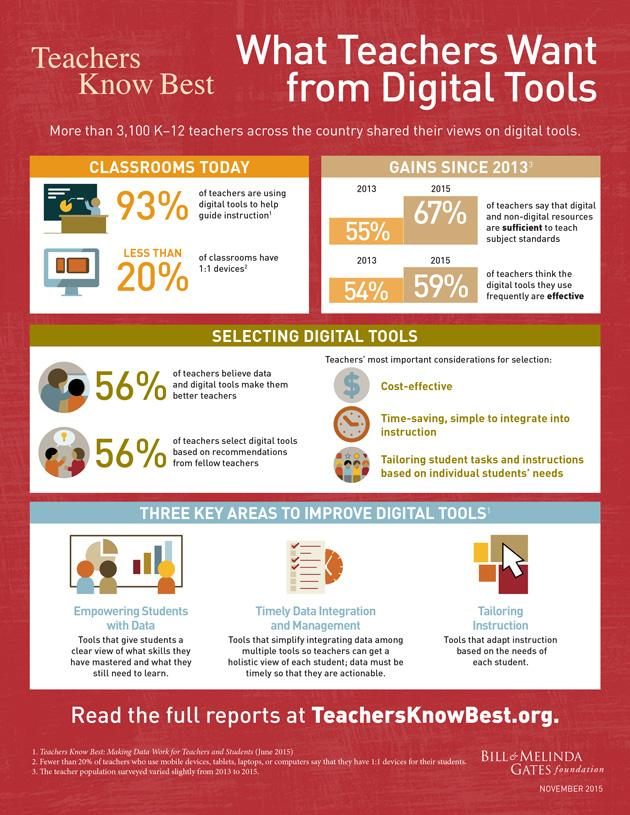Indicate a few pertinent items in this graphic. Through 2015, the gains have been considered. The class teachers who have completed the survey include those who teach K-12 students. A study revealed that a significant percentage of teachers do not use digital tools in their teaching. It is essential for educators to utilize digital tools that allow for personalized instruction that caters to the unique needs of each student, such as tailoring instruction based on individual learning styles and digital literacy levels. According to a survey of teachers, 44% do not follow recommendations to select digital tools. 